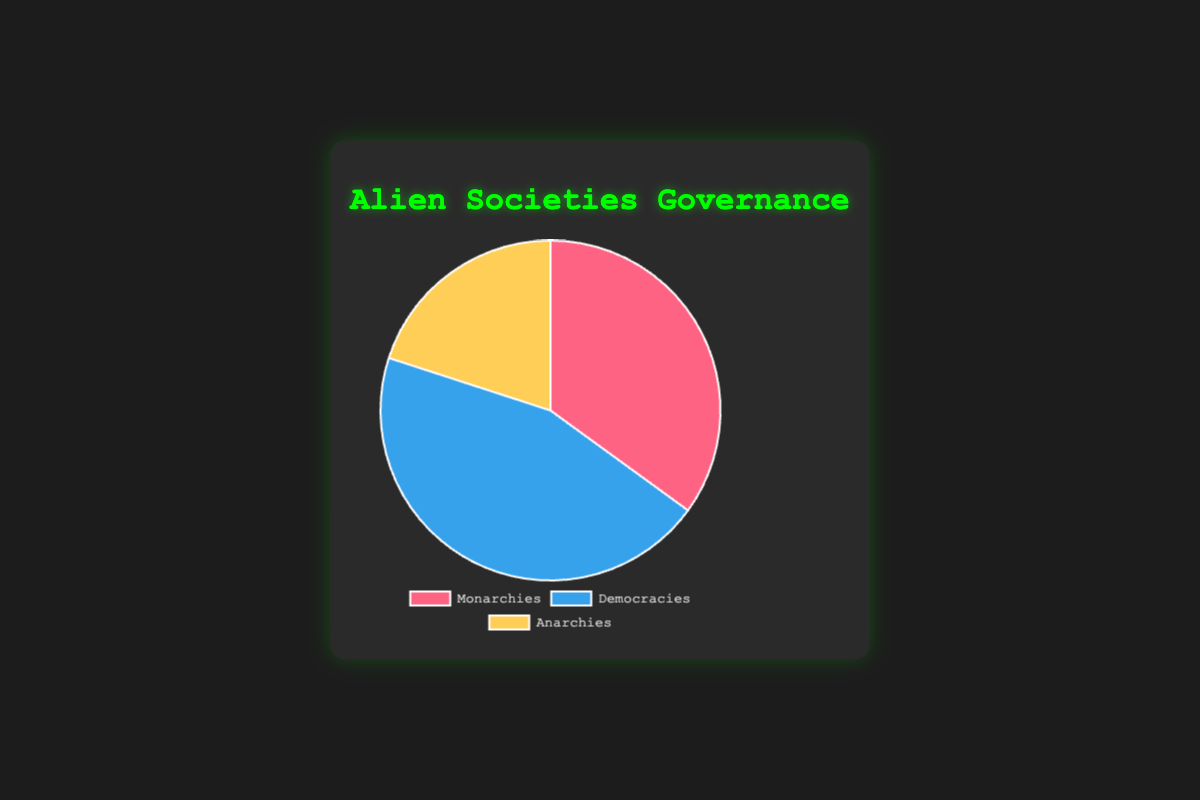What type of governance structure is the most common in alien societies? By examining the sizes of the pie chart slices, the largest slice represents Democracies, which occupies 45% of the chart.
Answer: Democracies What is the visual color representation for Monarchies in the pie chart? The pie chart uses distinct colors for each governance structure. Monarchies are represented in red.
Answer: Red How does the percentage of Anarchies compare to Monarchies? Anarchies make up 20% of the chart while Monarchies take up 35%. Therefore, Monarchies are more prevalent than Anarchies.
Answer: Monarchies are more prevalent What is the sum of the percentages of Monarchies and Anarchies? Monarchies account for 35%, and Anarchies account for 20%. Adding these together gives 35% + 20% = 55%.
Answer: 55% Which governance structure type has the smallest representation? Observing the pie chart slices, the smallest slice is for Anarchies, which make up 20% of the chart.
Answer: Anarchies By how much do Democracies exceed Anarchies in terms of percentage? Democracies occupy 45% while Anarchies occupy 20%. To find the difference: 45% - 20% = 25%.
Answer: 25% If the total number of alien societies is 100, how many of them are Democracies? Given that Democracies represent 45% of the chart, and if there are 100 societies in total, the number of Democracies would be 45% of 100, which is 45.
Answer: 45 Determine the average percentage representation of the three governance structures. The percentages for Monarchies, Democracies, and Anarchies are 35, 45, and 20 respectively. The average is calculated as (35% + 45% + 20%) / 3 = 100% / 3 ≈ 33.33%.
Answer: ≈ 33.33% How much more common are Monarchies than Anarchies in terms of percentage? Monarchies represent 35%, and Anarchies represent 20%. The difference between these two is 35% - 20% = 15%.
Answer: 15% What is the combined percentage of societies that are either Monarchies or Democracies? The percentage for Monarchies is 35%, and for Democracies, it is 45%. Adding these together gives 35% + 45% = 80%.
Answer: 80% 